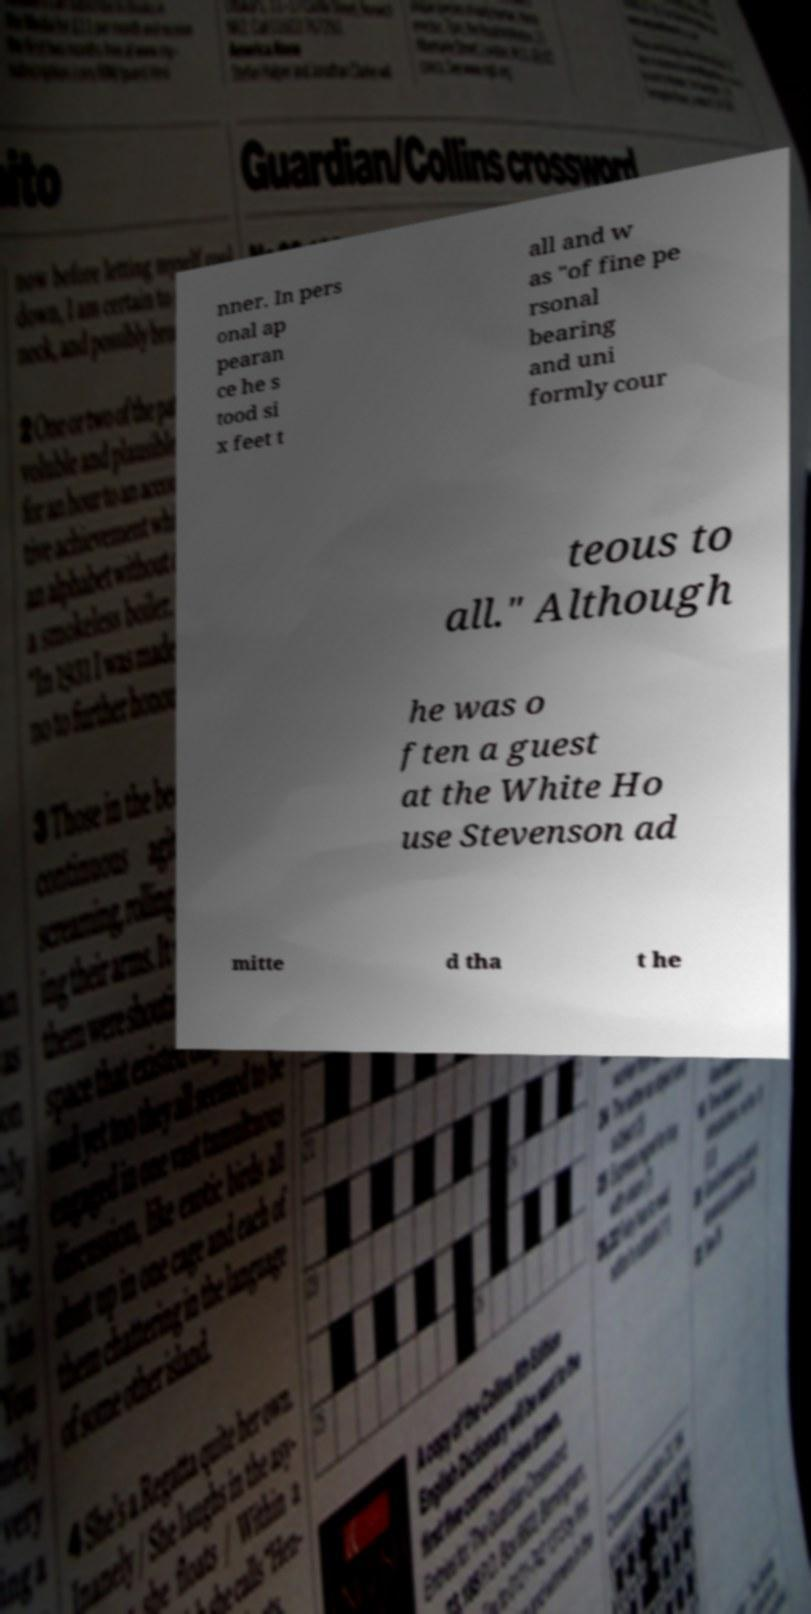There's text embedded in this image that I need extracted. Can you transcribe it verbatim? nner. In pers onal ap pearan ce he s tood si x feet t all and w as "of fine pe rsonal bearing and uni formly cour teous to all." Although he was o ften a guest at the White Ho use Stevenson ad mitte d tha t he 